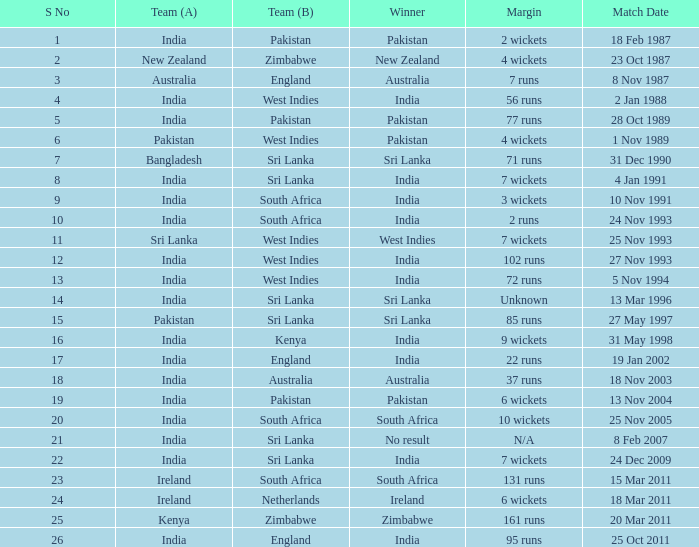How many games were won by a margin of 131 runs? 1.0. 